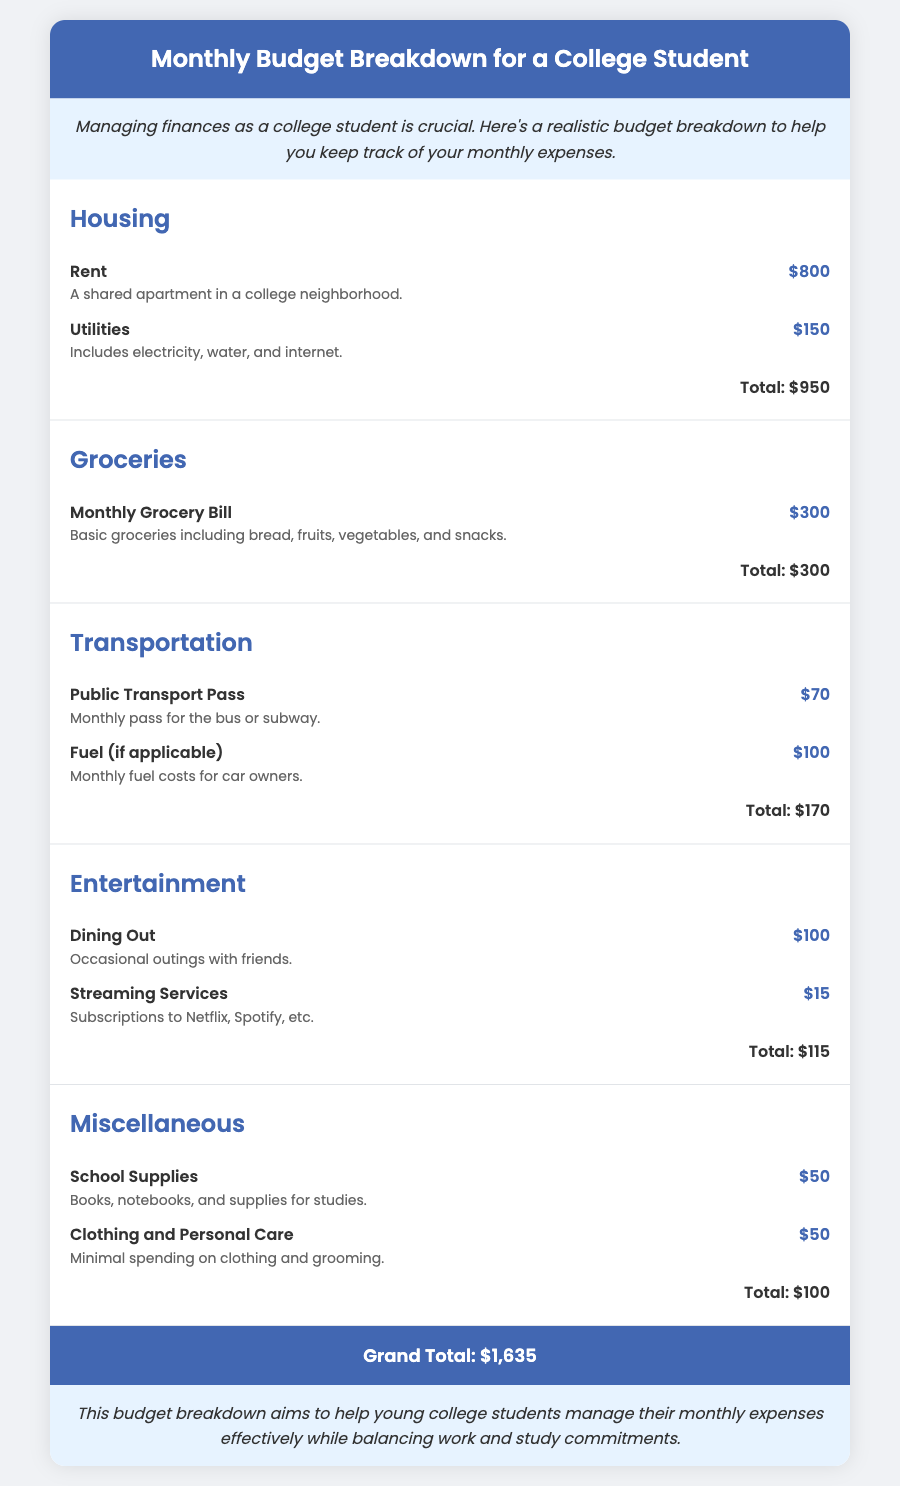What is the total cost for housing? The total cost for housing is the sum of rent and utilities, which is $800 + $150 = $950.
Answer: $950 How much is spent on groceries? The document specifies a monthly grocery bill, which is $300.
Answer: $300 What is the expense for entertainment? The total cost for entertainment, including dining out and streaming services, is $100 + $15 = $115.
Answer: $115 How much are utilities? Utilities include electricity, water, and internet, which cost $150.
Answer: $150 What is the grand total of all expenses? The grand total is the sum of all categories in the budget, which amounts to $1,635.
Answer: $1,635 What is included in the miscellaneous expenses? Miscellaneous expenses include school supplies and clothing/personal care, costing $50 each.
Answer: $100 How much is the cost for public transport? The monthly pass for public transport costs $70.
Answer: $70 What type of apartment is mentioned for rent? The document describes it as a shared apartment in a college neighborhood.
Answer: Shared apartment How much is allocated for dining out? The budget allocates $100 for dining out expenses.
Answer: $100 What service subscriptions are included in entertainment? Subscriptions mentioned are for Netflix and Spotify.
Answer: Netflix and Spotify 